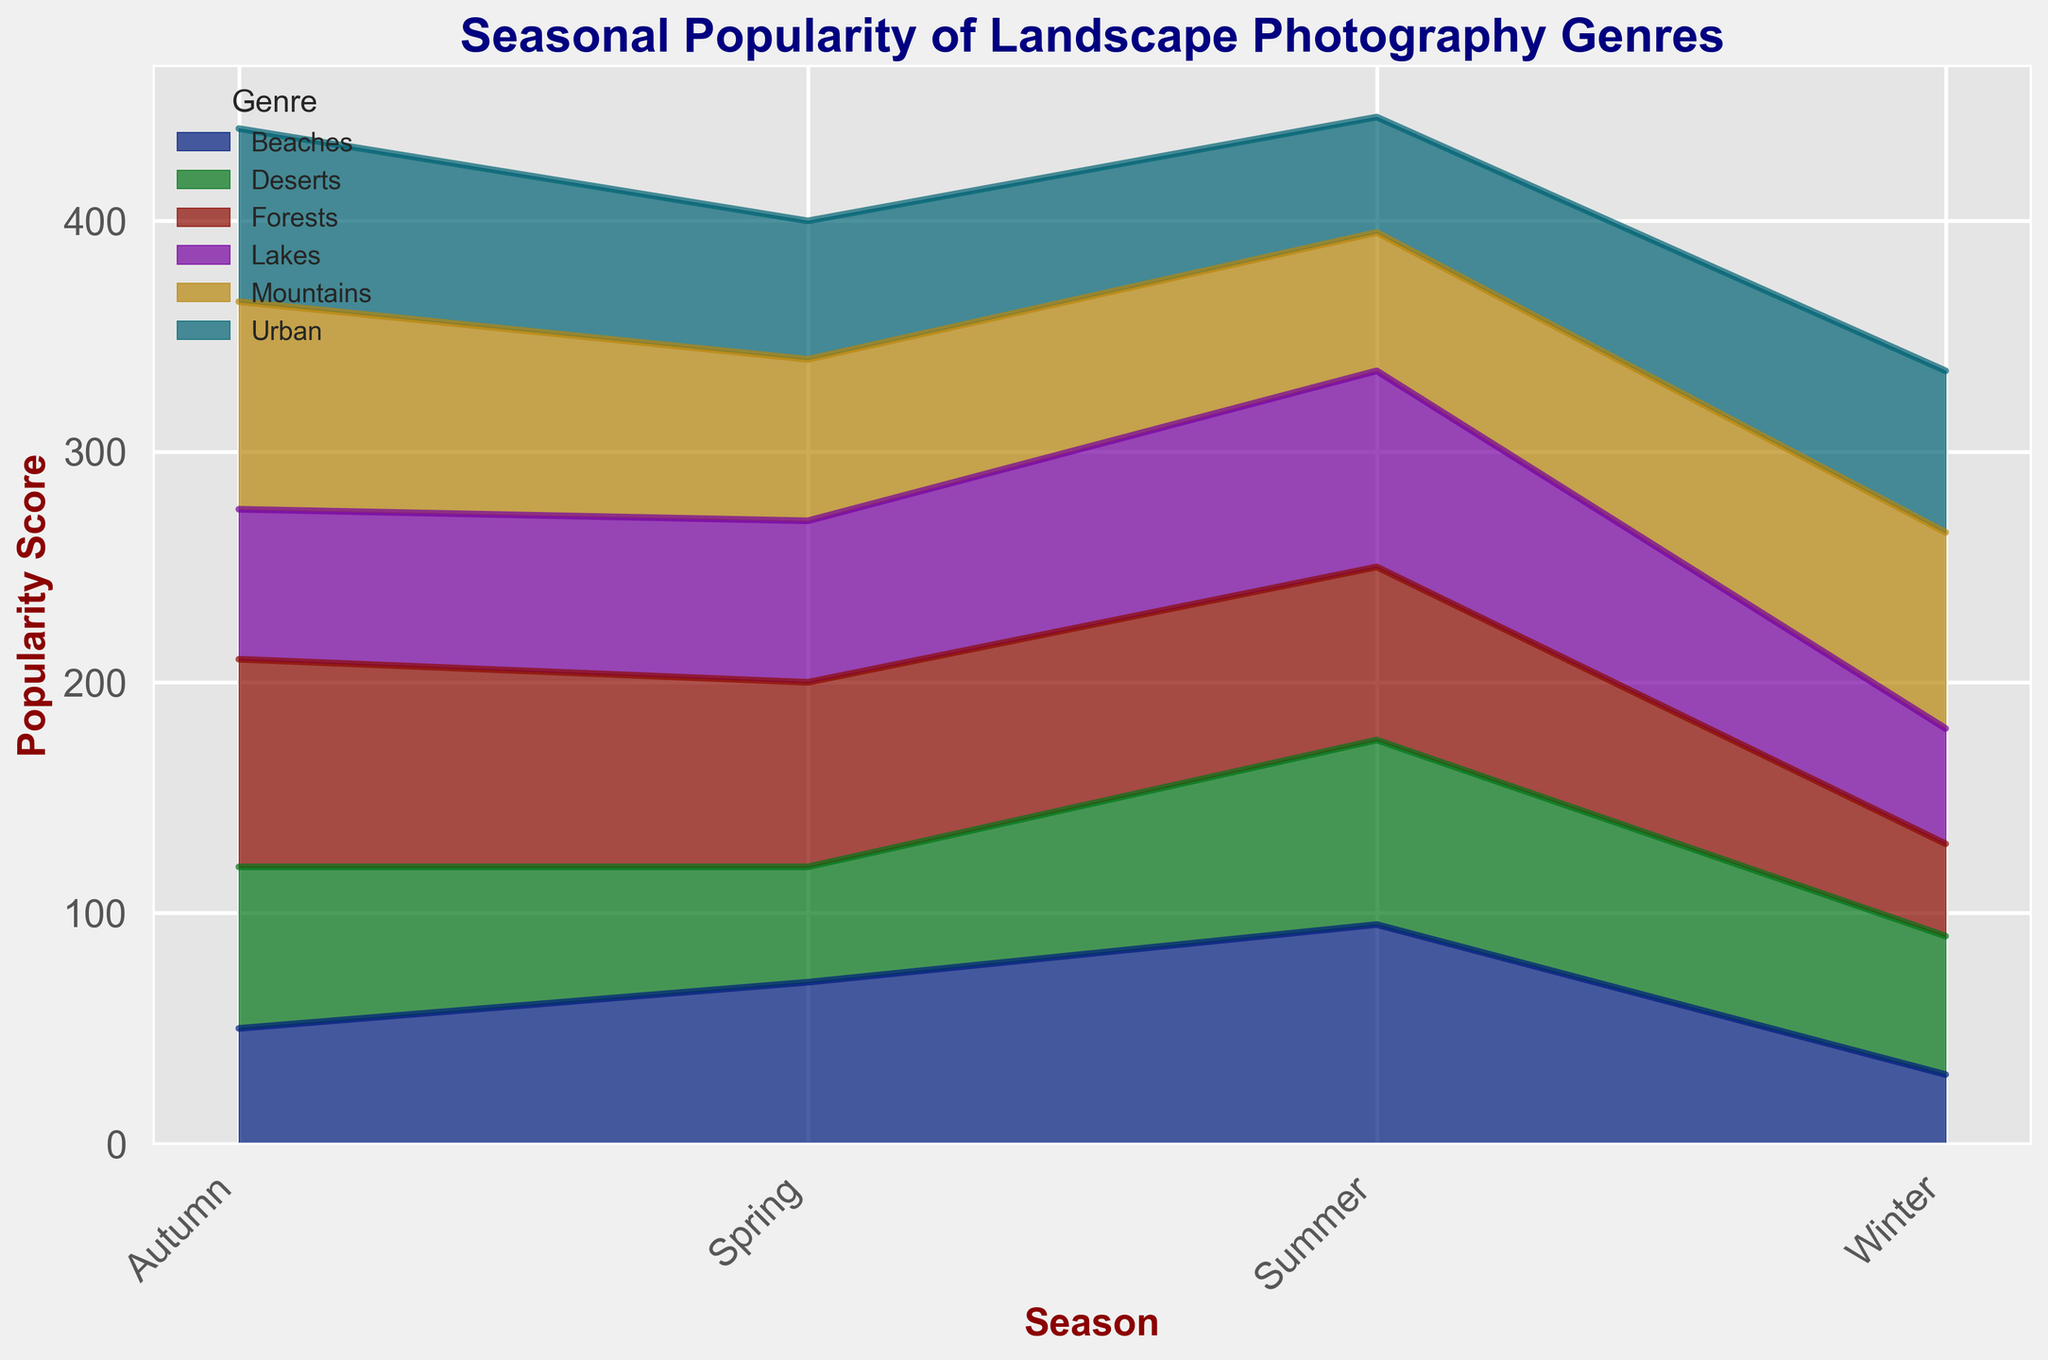Which genre has the highest popularity score in summer? Observe the area chart and identify the genre with the tallest area stack in the summer season. The Beaches genre has the tallest stack in summer.
Answer: Beaches Which genres peak in popularity during autumn? Observe the height of the areas in autumn. The genres with the highest stacks in autumn are Mountains and Forests.
Answer: Mountains and Forests Is the popularity of lakes in winter higher than urban landscapes in winter? Compare the area height for Lakes and Urban in the winter season. Lakes and Urban have stacks; Lakes appears lower.
Answer: No What is the combined popularity score of beaches and deserts in spring? Find the heights for Beaches and Deserts in spring and sum them up: 70 (Beaches) + 50 (Deserts).
Answer: 120 In which season is forest photography most popular? Look for the season where the Forests area is highest. The tallest stack for Forests is in Autumn.
Answer: Autumn Compare the popularity of deserts in summer to urban landscapes in summer. Which is higher, and by how much? Find the heights for Deserts and Urban in summer. Deserts is at 80; Urban is at 50. Difference = 80 - 50.
Answer: Deserts by 30 What is the average popularity score of lake photography across all seasons? Summarize the scores for Lakes over all seasons (50+70+85+65), divide by the number of seasons (4).
Answer: 67.5 Do mountains have a higher popularity in autumn compared to spring? Compare the areas for Mountains in autumn and spring. Autumn (90) is higher than Spring (70).
Answer: Yes Which genre has the least variability in popularity scores across seasons? Check the changes in height for each genre across seasons. Urban has relatively small changes (70, 60, 50, 75).
Answer: Urban Does forest photography have a higher popularity in spring than in winter? Compare the area heights for Forests in spring (80) and winter (40). Spring is higher.
Answer: Yes 